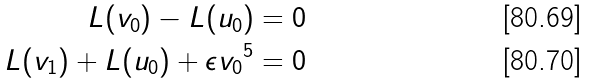<formula> <loc_0><loc_0><loc_500><loc_500>L ( v _ { 0 } ) - L ( u _ { 0 } ) = 0 \\ L ( v _ { 1 } ) + L ( u _ { 0 } ) + { \epsilon } { v _ { 0 } } ^ { 5 } = 0</formula> 